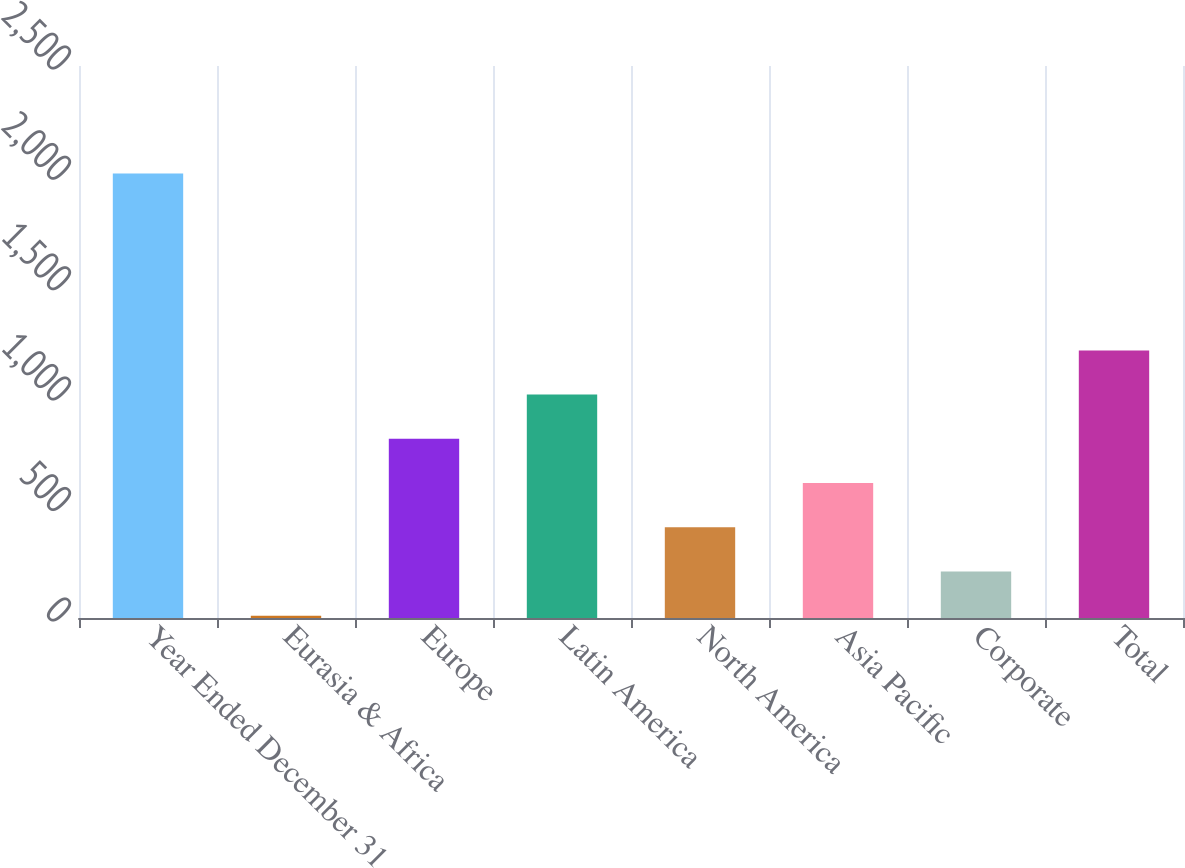<chart> <loc_0><loc_0><loc_500><loc_500><bar_chart><fcel>Year Ended December 31<fcel>Eurasia & Africa<fcel>Europe<fcel>Latin America<fcel>North America<fcel>Asia Pacific<fcel>Corporate<fcel>Total<nl><fcel>2013<fcel>10.6<fcel>811.56<fcel>1011.8<fcel>411.08<fcel>611.32<fcel>210.84<fcel>1212.04<nl></chart> 